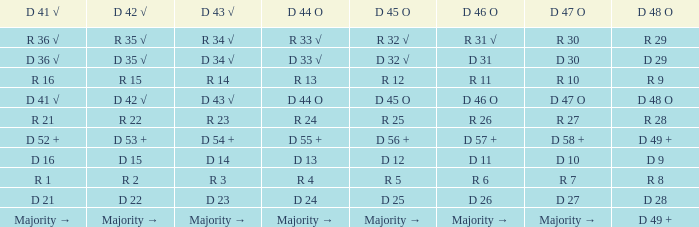Name the D 45 O with D 44 O majority → Majority →. 